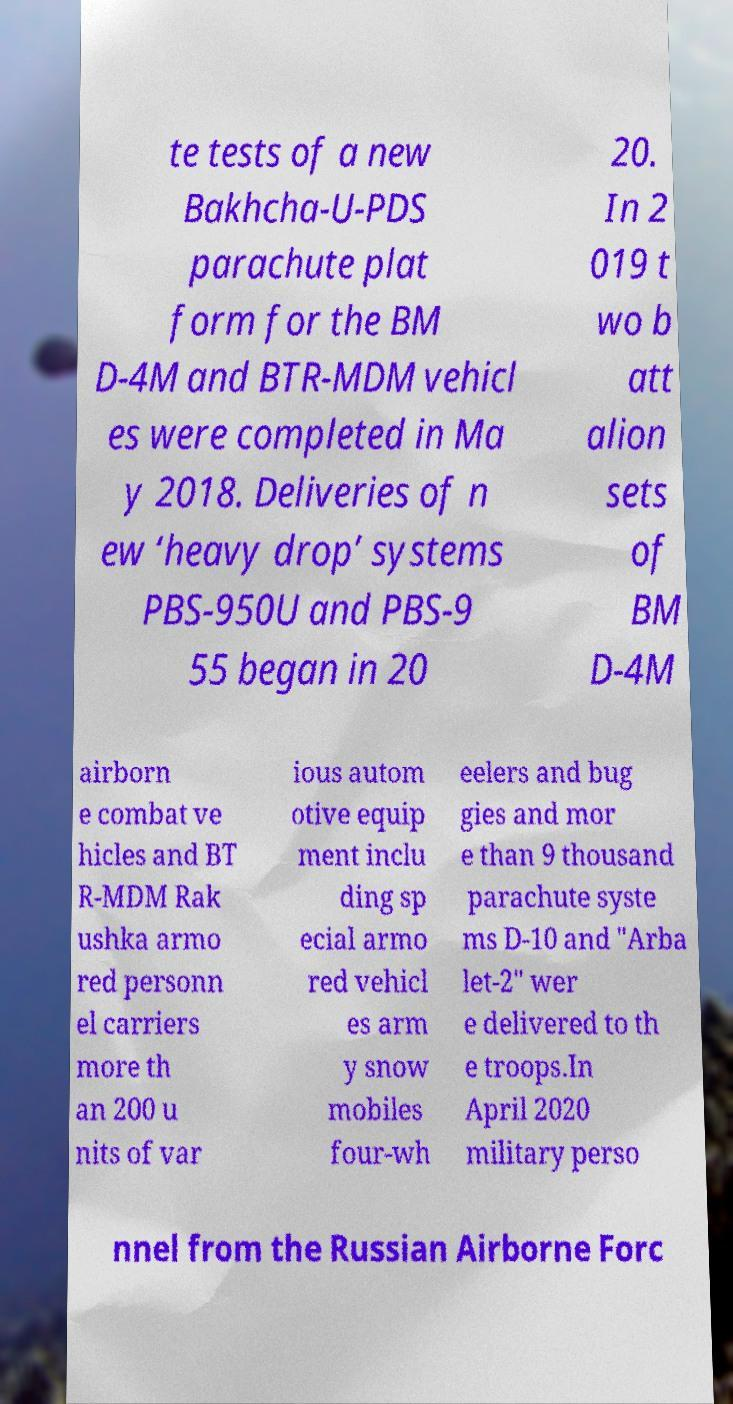There's text embedded in this image that I need extracted. Can you transcribe it verbatim? te tests of a new Bakhcha-U-PDS parachute plat form for the BM D-4M and BTR-MDM vehicl es were completed in Ma y 2018. Deliveries of n ew ‘heavy drop’ systems PBS-950U and PBS-9 55 began in 20 20. In 2 019 t wo b att alion sets of BM D-4M airborn e combat ve hicles and BT R-MDM Rak ushka armo red personn el carriers more th an 200 u nits of var ious autom otive equip ment inclu ding sp ecial armo red vehicl es arm y snow mobiles four-wh eelers and bug gies and mor e than 9 thousand parachute syste ms D-10 and "Arba let-2" wer e delivered to th e troops.In April 2020 military perso nnel from the Russian Airborne Forc 